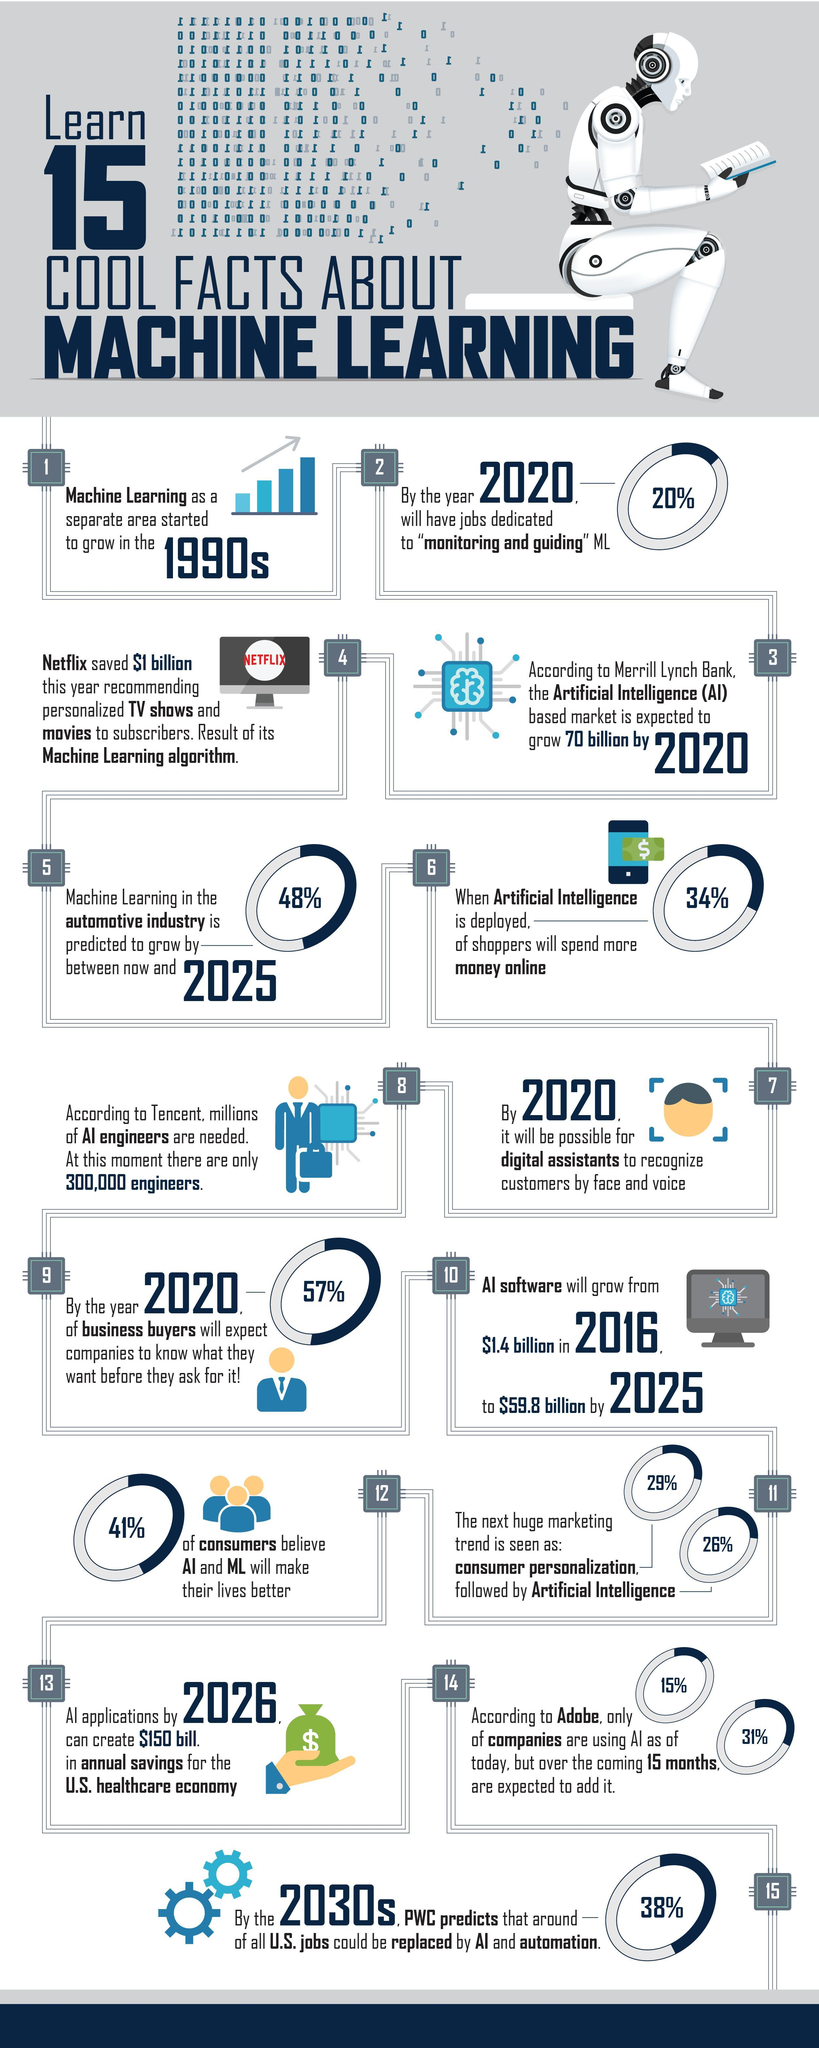What percentage of money is more spend for online shopping when AI is deployed?
Answer the question with a short phrase. 34% What percentage growth of machine learning is predicted in the automotive industry by 2025? 48% What percentage of consumers do not believe that AI & ML will make their lives better? 59% What is the expected percentage of monitoring & guiding  ML jobs in 2020? 20% 